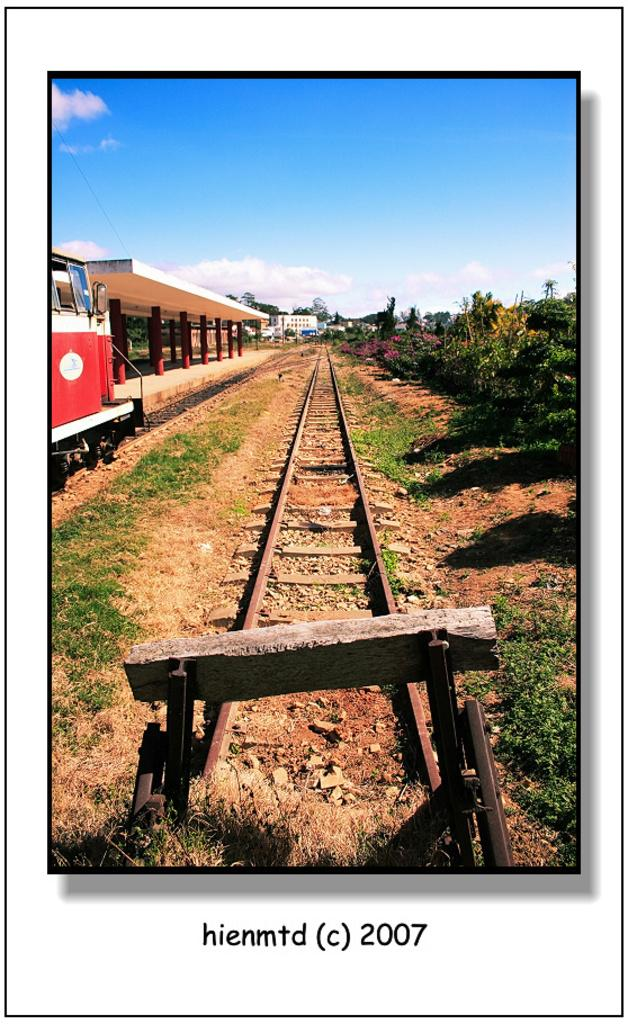<image>
Offer a succinct explanation of the picture presented. A long, narrow train track photographed in 2007. 